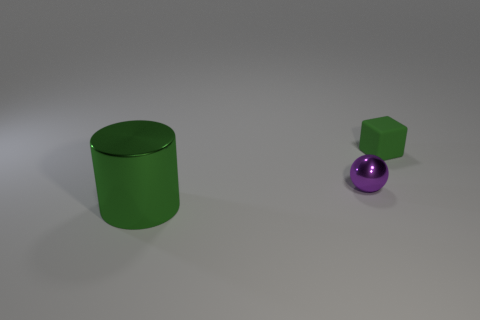Add 3 big things. How many objects exist? 6 Subtract all blocks. How many objects are left? 2 Subtract 0 red balls. How many objects are left? 3 Subtract all blue things. Subtract all green matte blocks. How many objects are left? 2 Add 3 metal things. How many metal things are left? 5 Add 2 green objects. How many green objects exist? 4 